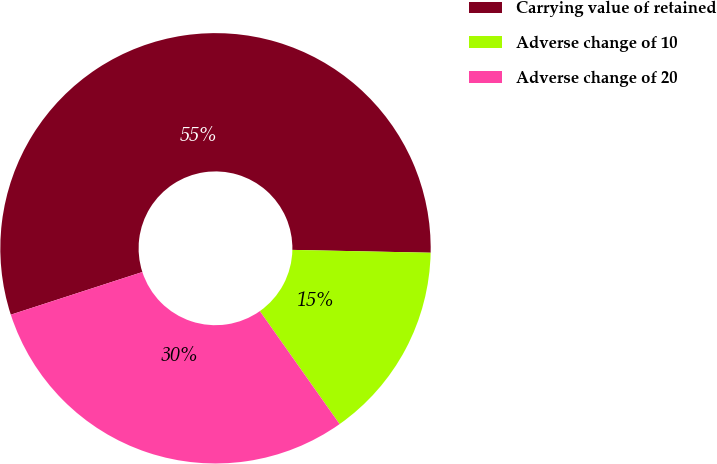Convert chart. <chart><loc_0><loc_0><loc_500><loc_500><pie_chart><fcel>Carrying value of retained<fcel>Adverse change of 10<fcel>Adverse change of 20<nl><fcel>55.32%<fcel>14.89%<fcel>29.79%<nl></chart> 